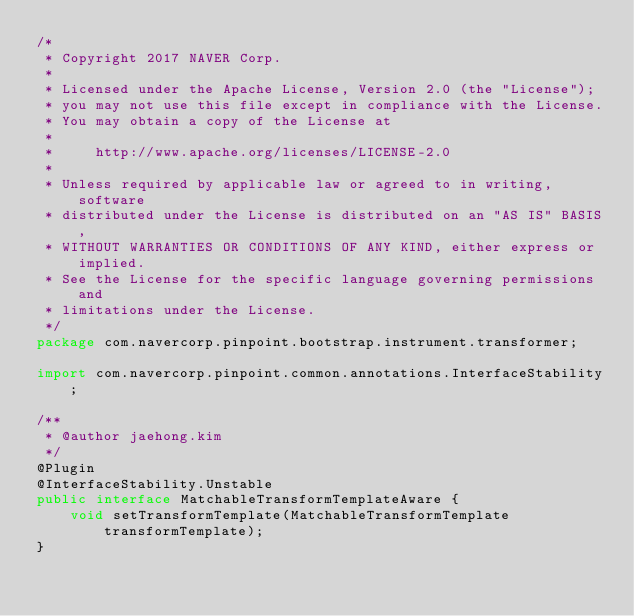<code> <loc_0><loc_0><loc_500><loc_500><_Java_>/*
 * Copyright 2017 NAVER Corp.
 *
 * Licensed under the Apache License, Version 2.0 (the "License");
 * you may not use this file except in compliance with the License.
 * You may obtain a copy of the License at
 *
 *     http://www.apache.org/licenses/LICENSE-2.0
 *
 * Unless required by applicable law or agreed to in writing, software
 * distributed under the License is distributed on an "AS IS" BASIS,
 * WITHOUT WARRANTIES OR CONDITIONS OF ANY KIND, either express or implied.
 * See the License for the specific language governing permissions and
 * limitations under the License.
 */
package com.navercorp.pinpoint.bootstrap.instrument.transformer;

import com.navercorp.pinpoint.common.annotations.InterfaceStability;

/**
 * @author jaehong.kim
 */
@Plugin
@InterfaceStability.Unstable
public interface MatchableTransformTemplateAware {
    void setTransformTemplate(MatchableTransformTemplate transformTemplate);
}</code> 